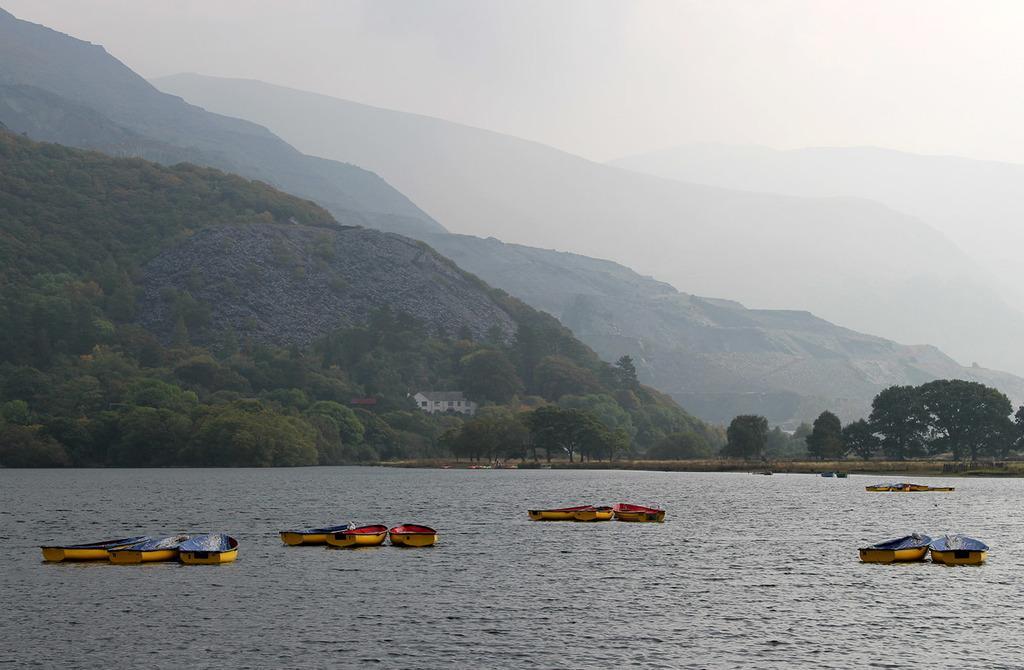Please provide a concise description of this image. In this picture we can see boats on the water. In the background of the image we can see hills, trees, house and sky. 